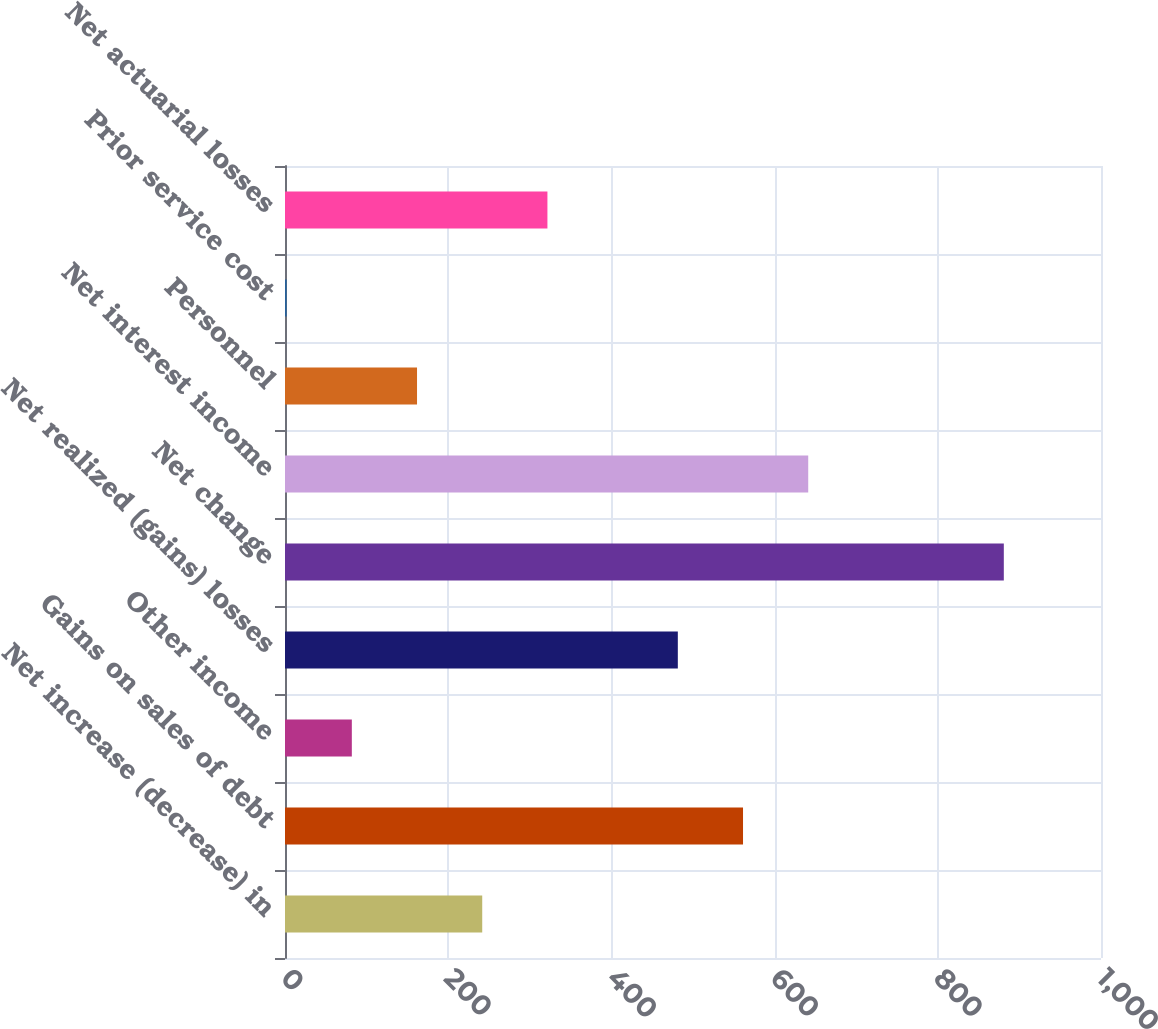Convert chart to OTSL. <chart><loc_0><loc_0><loc_500><loc_500><bar_chart><fcel>Net increase (decrease) in<fcel>Gains on sales of debt<fcel>Other income<fcel>Net realized (gains) losses<fcel>Net change<fcel>Net interest income<fcel>Personnel<fcel>Prior service cost<fcel>Net actuarial losses<nl><fcel>241.7<fcel>561.3<fcel>81.9<fcel>481.4<fcel>880.9<fcel>641.2<fcel>161.8<fcel>2<fcel>321.6<nl></chart> 